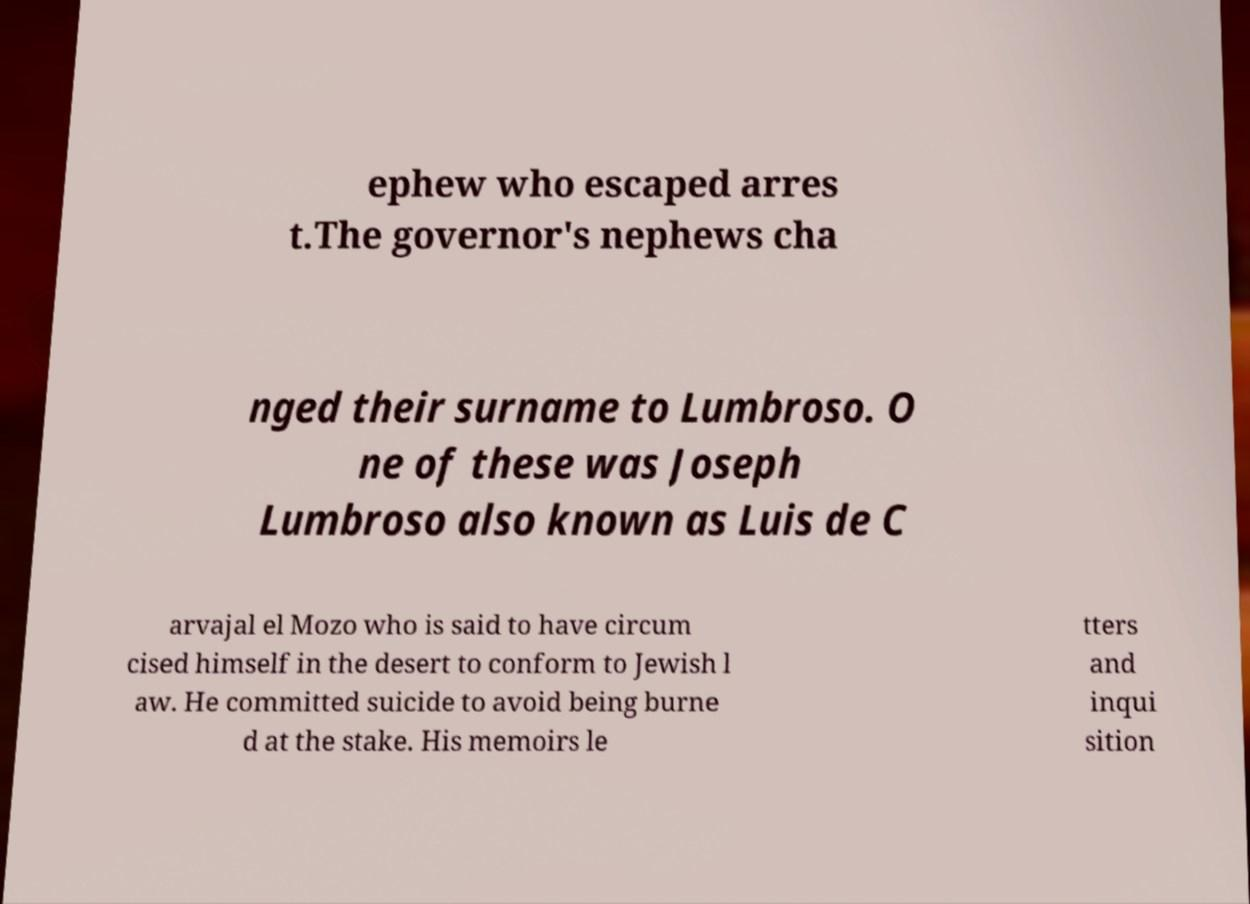Can you accurately transcribe the text from the provided image for me? ephew who escaped arres t.The governor's nephews cha nged their surname to Lumbroso. O ne of these was Joseph Lumbroso also known as Luis de C arvajal el Mozo who is said to have circum cised himself in the desert to conform to Jewish l aw. He committed suicide to avoid being burne d at the stake. His memoirs le tters and inqui sition 